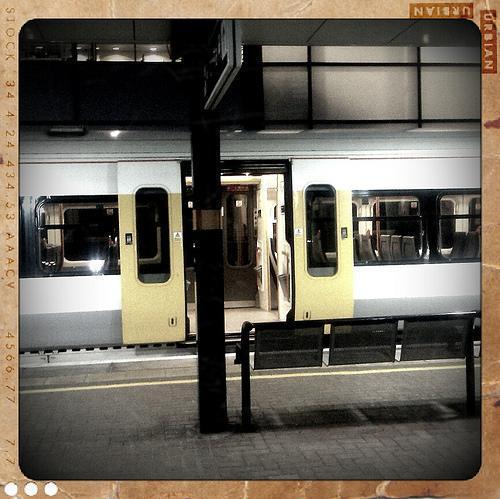How many seats are on the bench?
Give a very brief answer. 3. How many train doors are open?
Give a very brief answer. 1. How many signs are on the pole next to the bench?
Give a very brief answer. 1. How many people are sitting on the bench?
Give a very brief answer. 0. 